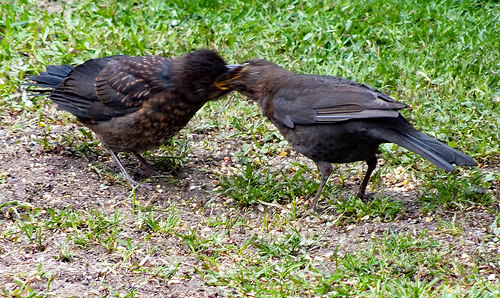<image>
Is the bird in the grass? Yes. The bird is contained within or inside the grass, showing a containment relationship. 